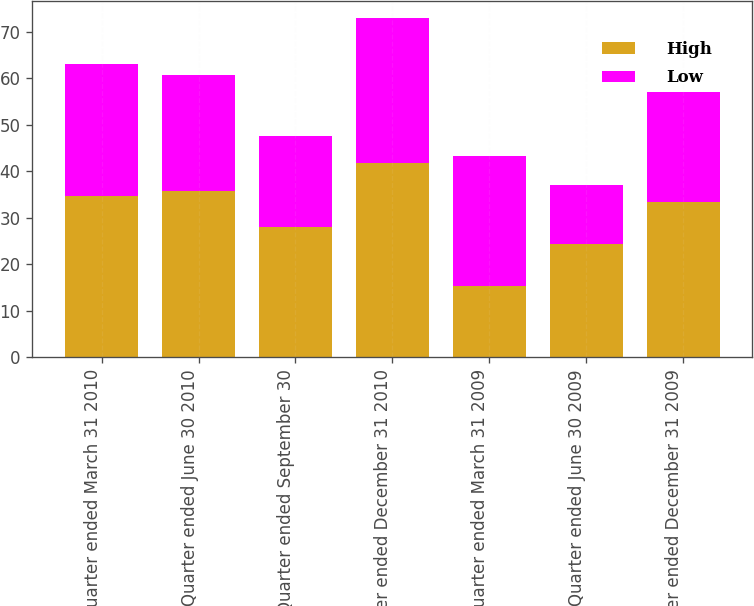Convert chart to OTSL. <chart><loc_0><loc_0><loc_500><loc_500><stacked_bar_chart><ecel><fcel>Quarter ended March 31 2010<fcel>Quarter ended June 30 2010<fcel>Quarter ended September 30<fcel>Quarter ended December 31 2010<fcel>Quarter ended March 31 2009<fcel>Quarter ended June 30 2009<fcel>Quarter ended December 31 2009<nl><fcel>High<fcel>34.77<fcel>35.83<fcel>27.93<fcel>41.74<fcel>15.27<fcel>24.3<fcel>33.41<nl><fcel>Low<fcel>28.2<fcel>24.84<fcel>19.72<fcel>31.22<fcel>27.93<fcel>12.67<fcel>23.65<nl></chart> 